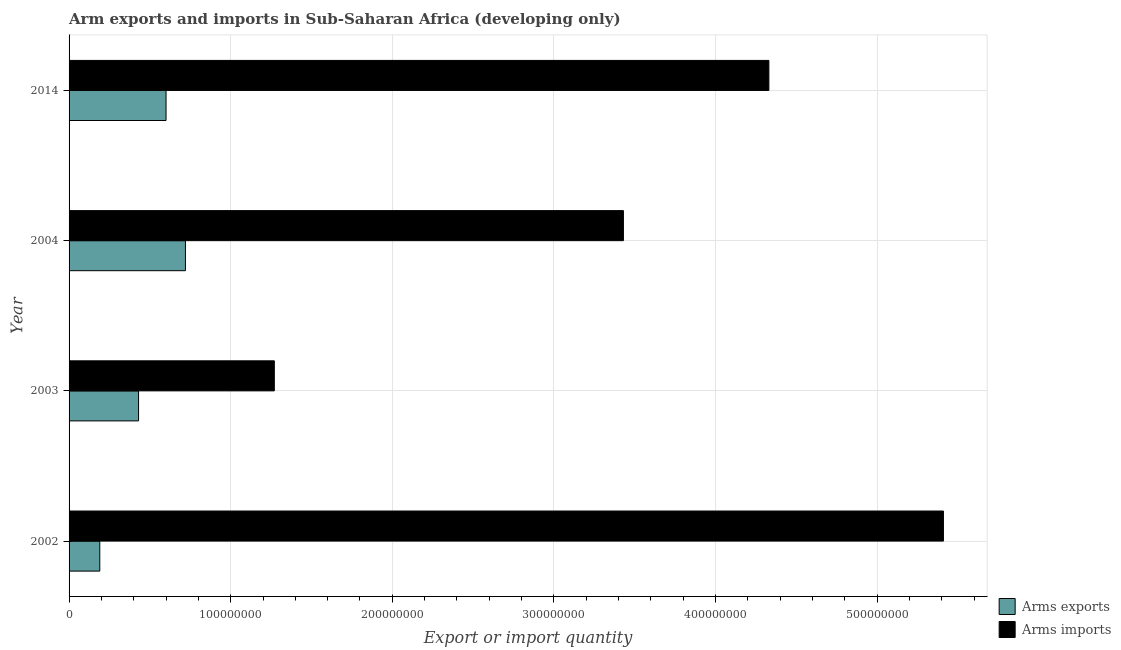How many groups of bars are there?
Provide a short and direct response. 4. Are the number of bars per tick equal to the number of legend labels?
Provide a succinct answer. Yes. How many bars are there on the 4th tick from the bottom?
Provide a succinct answer. 2. In how many cases, is the number of bars for a given year not equal to the number of legend labels?
Ensure brevity in your answer.  0. What is the arms imports in 2014?
Provide a short and direct response. 4.33e+08. Across all years, what is the maximum arms imports?
Offer a terse response. 5.41e+08. Across all years, what is the minimum arms exports?
Your response must be concise. 1.90e+07. In which year was the arms imports maximum?
Give a very brief answer. 2002. What is the total arms imports in the graph?
Ensure brevity in your answer.  1.44e+09. What is the difference between the arms exports in 2004 and that in 2014?
Your response must be concise. 1.20e+07. What is the difference between the arms imports in 2004 and the arms exports in 2014?
Ensure brevity in your answer.  2.83e+08. What is the average arms imports per year?
Give a very brief answer. 3.61e+08. In the year 2003, what is the difference between the arms imports and arms exports?
Give a very brief answer. 8.40e+07. What is the ratio of the arms exports in 2003 to that in 2004?
Your response must be concise. 0.6. Is the arms imports in 2002 less than that in 2004?
Your answer should be very brief. No. Is the difference between the arms imports in 2003 and 2014 greater than the difference between the arms exports in 2003 and 2014?
Offer a very short reply. No. What is the difference between the highest and the second highest arms imports?
Keep it short and to the point. 1.08e+08. What is the difference between the highest and the lowest arms exports?
Your response must be concise. 5.30e+07. What does the 2nd bar from the top in 2004 represents?
Give a very brief answer. Arms exports. What does the 2nd bar from the bottom in 2002 represents?
Make the answer very short. Arms imports. How many years are there in the graph?
Provide a succinct answer. 4. What is the difference between two consecutive major ticks on the X-axis?
Provide a short and direct response. 1.00e+08. Are the values on the major ticks of X-axis written in scientific E-notation?
Your answer should be very brief. No. Does the graph contain any zero values?
Ensure brevity in your answer.  No. Does the graph contain grids?
Provide a short and direct response. Yes. How many legend labels are there?
Provide a succinct answer. 2. What is the title of the graph?
Offer a very short reply. Arm exports and imports in Sub-Saharan Africa (developing only). Does "Canada" appear as one of the legend labels in the graph?
Give a very brief answer. No. What is the label or title of the X-axis?
Provide a short and direct response. Export or import quantity. What is the label or title of the Y-axis?
Your response must be concise. Year. What is the Export or import quantity in Arms exports in 2002?
Give a very brief answer. 1.90e+07. What is the Export or import quantity of Arms imports in 2002?
Ensure brevity in your answer.  5.41e+08. What is the Export or import quantity in Arms exports in 2003?
Your response must be concise. 4.30e+07. What is the Export or import quantity in Arms imports in 2003?
Provide a short and direct response. 1.27e+08. What is the Export or import quantity of Arms exports in 2004?
Give a very brief answer. 7.20e+07. What is the Export or import quantity in Arms imports in 2004?
Keep it short and to the point. 3.43e+08. What is the Export or import quantity in Arms exports in 2014?
Provide a succinct answer. 6.00e+07. What is the Export or import quantity in Arms imports in 2014?
Make the answer very short. 4.33e+08. Across all years, what is the maximum Export or import quantity in Arms exports?
Your answer should be very brief. 7.20e+07. Across all years, what is the maximum Export or import quantity of Arms imports?
Give a very brief answer. 5.41e+08. Across all years, what is the minimum Export or import quantity of Arms exports?
Give a very brief answer. 1.90e+07. Across all years, what is the minimum Export or import quantity in Arms imports?
Offer a very short reply. 1.27e+08. What is the total Export or import quantity in Arms exports in the graph?
Your answer should be very brief. 1.94e+08. What is the total Export or import quantity of Arms imports in the graph?
Offer a very short reply. 1.44e+09. What is the difference between the Export or import quantity of Arms exports in 2002 and that in 2003?
Offer a terse response. -2.40e+07. What is the difference between the Export or import quantity in Arms imports in 2002 and that in 2003?
Your response must be concise. 4.14e+08. What is the difference between the Export or import quantity of Arms exports in 2002 and that in 2004?
Provide a succinct answer. -5.30e+07. What is the difference between the Export or import quantity of Arms imports in 2002 and that in 2004?
Your response must be concise. 1.98e+08. What is the difference between the Export or import quantity of Arms exports in 2002 and that in 2014?
Offer a terse response. -4.10e+07. What is the difference between the Export or import quantity of Arms imports in 2002 and that in 2014?
Your answer should be compact. 1.08e+08. What is the difference between the Export or import quantity in Arms exports in 2003 and that in 2004?
Your answer should be very brief. -2.90e+07. What is the difference between the Export or import quantity in Arms imports in 2003 and that in 2004?
Provide a succinct answer. -2.16e+08. What is the difference between the Export or import quantity in Arms exports in 2003 and that in 2014?
Ensure brevity in your answer.  -1.70e+07. What is the difference between the Export or import quantity of Arms imports in 2003 and that in 2014?
Your answer should be compact. -3.06e+08. What is the difference between the Export or import quantity in Arms exports in 2004 and that in 2014?
Your response must be concise. 1.20e+07. What is the difference between the Export or import quantity in Arms imports in 2004 and that in 2014?
Ensure brevity in your answer.  -9.00e+07. What is the difference between the Export or import quantity in Arms exports in 2002 and the Export or import quantity in Arms imports in 2003?
Make the answer very short. -1.08e+08. What is the difference between the Export or import quantity in Arms exports in 2002 and the Export or import quantity in Arms imports in 2004?
Offer a terse response. -3.24e+08. What is the difference between the Export or import quantity in Arms exports in 2002 and the Export or import quantity in Arms imports in 2014?
Offer a terse response. -4.14e+08. What is the difference between the Export or import quantity in Arms exports in 2003 and the Export or import quantity in Arms imports in 2004?
Keep it short and to the point. -3.00e+08. What is the difference between the Export or import quantity in Arms exports in 2003 and the Export or import quantity in Arms imports in 2014?
Make the answer very short. -3.90e+08. What is the difference between the Export or import quantity of Arms exports in 2004 and the Export or import quantity of Arms imports in 2014?
Offer a very short reply. -3.61e+08. What is the average Export or import quantity of Arms exports per year?
Your answer should be compact. 4.85e+07. What is the average Export or import quantity in Arms imports per year?
Provide a short and direct response. 3.61e+08. In the year 2002, what is the difference between the Export or import quantity of Arms exports and Export or import quantity of Arms imports?
Offer a terse response. -5.22e+08. In the year 2003, what is the difference between the Export or import quantity in Arms exports and Export or import quantity in Arms imports?
Your response must be concise. -8.40e+07. In the year 2004, what is the difference between the Export or import quantity in Arms exports and Export or import quantity in Arms imports?
Provide a succinct answer. -2.71e+08. In the year 2014, what is the difference between the Export or import quantity of Arms exports and Export or import quantity of Arms imports?
Give a very brief answer. -3.73e+08. What is the ratio of the Export or import quantity in Arms exports in 2002 to that in 2003?
Provide a short and direct response. 0.44. What is the ratio of the Export or import quantity of Arms imports in 2002 to that in 2003?
Give a very brief answer. 4.26. What is the ratio of the Export or import quantity of Arms exports in 2002 to that in 2004?
Offer a very short reply. 0.26. What is the ratio of the Export or import quantity in Arms imports in 2002 to that in 2004?
Make the answer very short. 1.58. What is the ratio of the Export or import quantity of Arms exports in 2002 to that in 2014?
Your answer should be very brief. 0.32. What is the ratio of the Export or import quantity of Arms imports in 2002 to that in 2014?
Provide a short and direct response. 1.25. What is the ratio of the Export or import quantity of Arms exports in 2003 to that in 2004?
Make the answer very short. 0.6. What is the ratio of the Export or import quantity of Arms imports in 2003 to that in 2004?
Your answer should be very brief. 0.37. What is the ratio of the Export or import quantity in Arms exports in 2003 to that in 2014?
Keep it short and to the point. 0.72. What is the ratio of the Export or import quantity in Arms imports in 2003 to that in 2014?
Keep it short and to the point. 0.29. What is the ratio of the Export or import quantity in Arms imports in 2004 to that in 2014?
Provide a succinct answer. 0.79. What is the difference between the highest and the second highest Export or import quantity of Arms exports?
Your answer should be very brief. 1.20e+07. What is the difference between the highest and the second highest Export or import quantity of Arms imports?
Offer a terse response. 1.08e+08. What is the difference between the highest and the lowest Export or import quantity of Arms exports?
Make the answer very short. 5.30e+07. What is the difference between the highest and the lowest Export or import quantity in Arms imports?
Provide a succinct answer. 4.14e+08. 